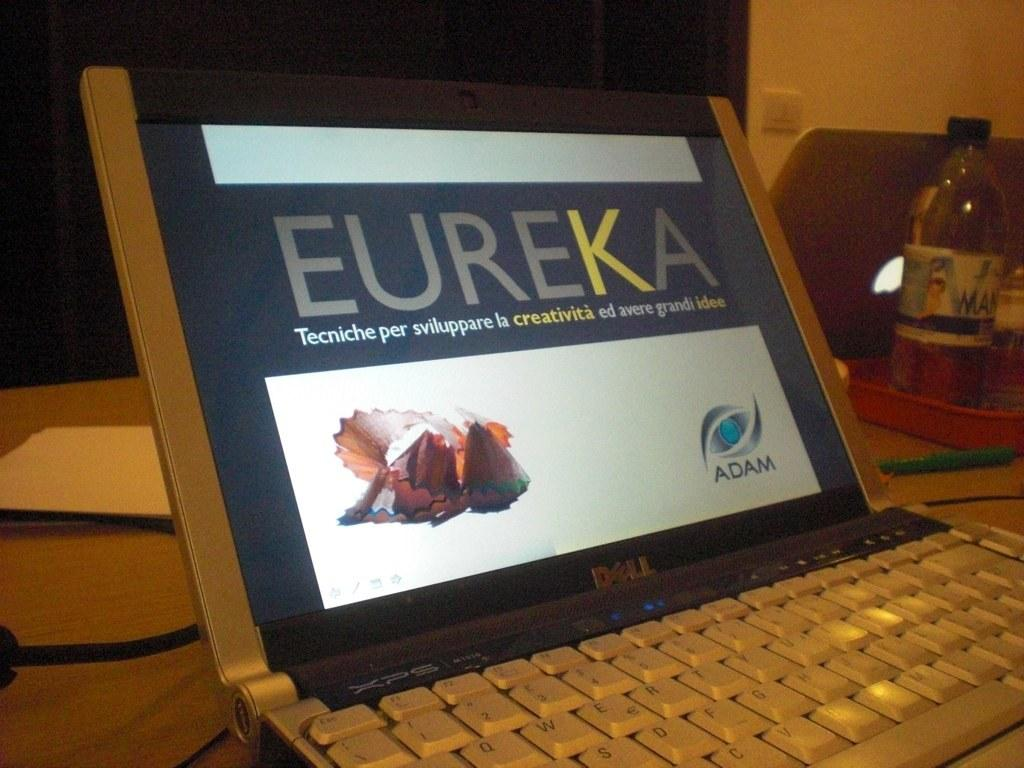<image>
Summarize the visual content of the image. a dell laptop is open to a eureka site 